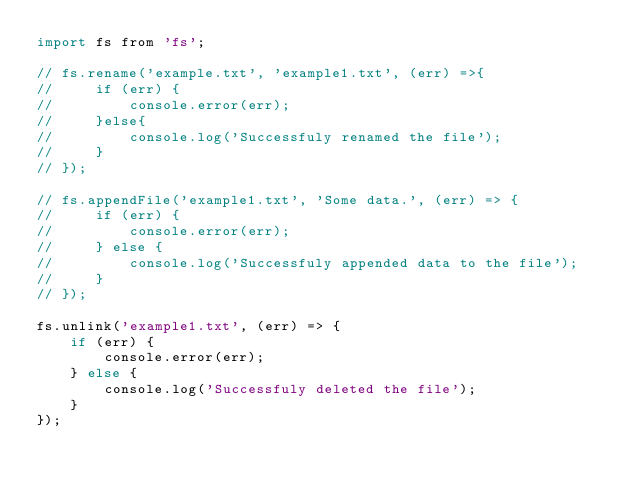<code> <loc_0><loc_0><loc_500><loc_500><_JavaScript_>import fs from 'fs';

// fs.rename('example.txt', 'example1.txt', (err) =>{
//     if (err) {
//         console.error(err);
//     }else{
//         console.log('Successfuly renamed the file');
//     }
// });

// fs.appendFile('example1.txt', 'Some data.', (err) => {
//     if (err) {
//         console.error(err);
//     } else {
//         console.log('Successfuly appended data to the file');
//     }
// });

fs.unlink('example1.txt', (err) => {
    if (err) {
        console.error(err);
    } else {
        console.log('Successfuly deleted the file');
    }
});</code> 